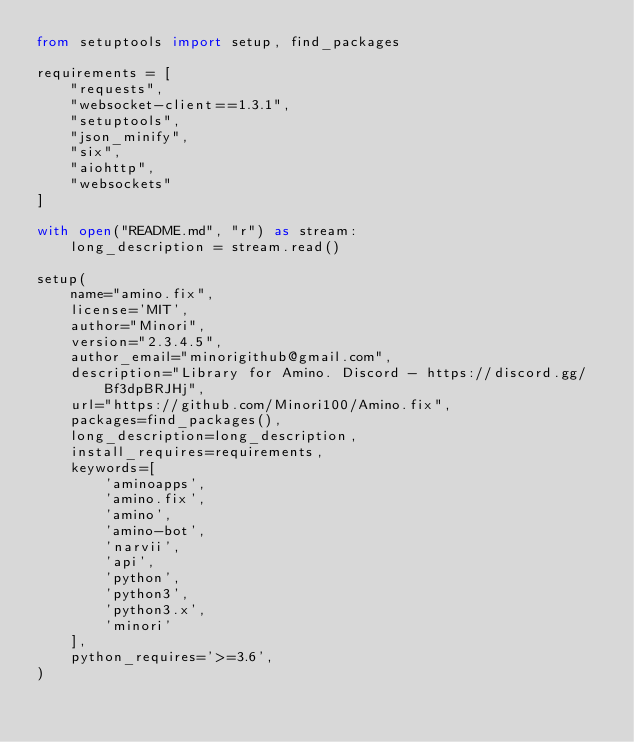Convert code to text. <code><loc_0><loc_0><loc_500><loc_500><_Python_>from setuptools import setup, find_packages

requirements = [
    "requests",
    "websocket-client==1.3.1", 
    "setuptools", 
    "json_minify", 
    "six",
    "aiohttp",
    "websockets"
]

with open("README.md", "r") as stream:
    long_description = stream.read()

setup(
    name="amino.fix",
    license='MIT',
    author="Minori",
    version="2.3.4.5",
    author_email="minorigithub@gmail.com",
    description="Library for Amino. Discord - https://discord.gg/Bf3dpBRJHj",
    url="https://github.com/Minori100/Amino.fix",
    packages=find_packages(),
    long_description=long_description,
    install_requires=requirements,
    keywords=[
        'aminoapps',
        'amino.fix',
        'amino',
        'amino-bot',
        'narvii',
        'api',
        'python',
        'python3',
        'python3.x',
        'minori'
    ],
    python_requires='>=3.6',
)
</code> 